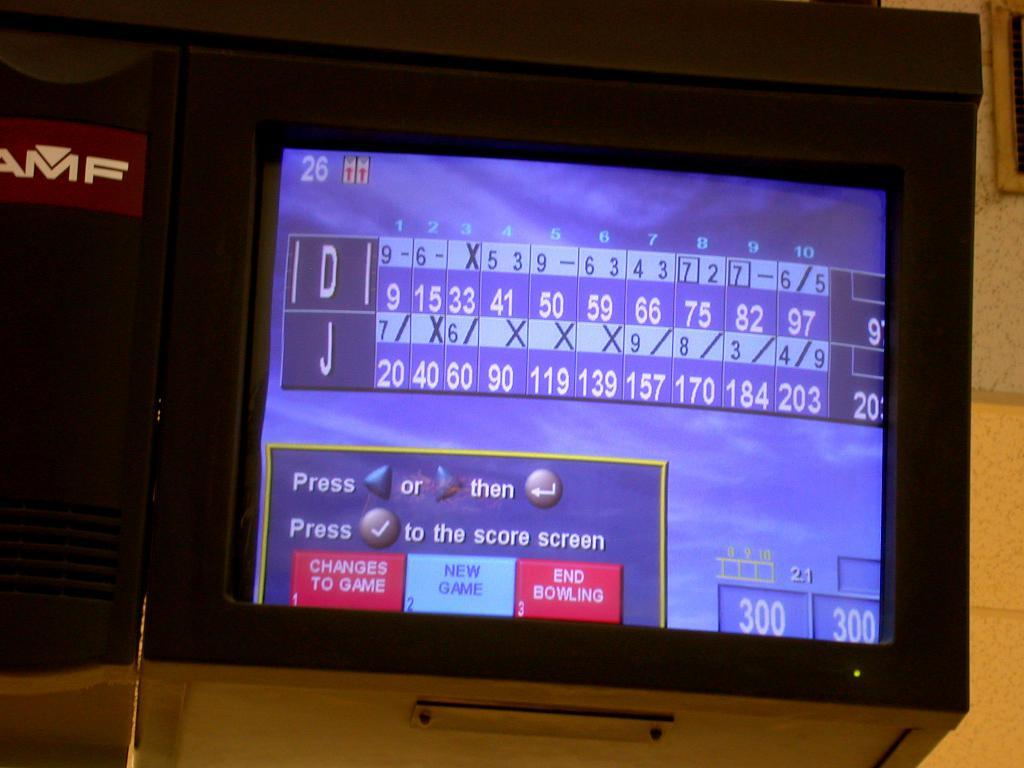<image>
Create a compact narrative representing the image presented. A television screen is showing the scores for a bowling game with the initials J and D on either column. 